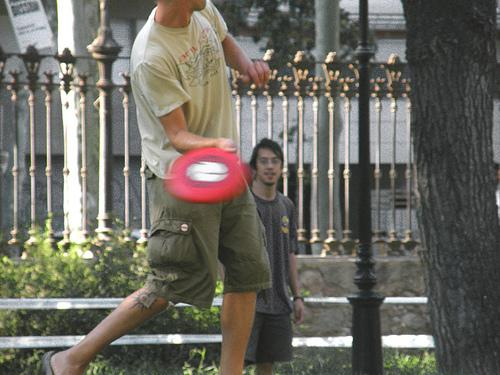What is tattooed on his right leg? sun 